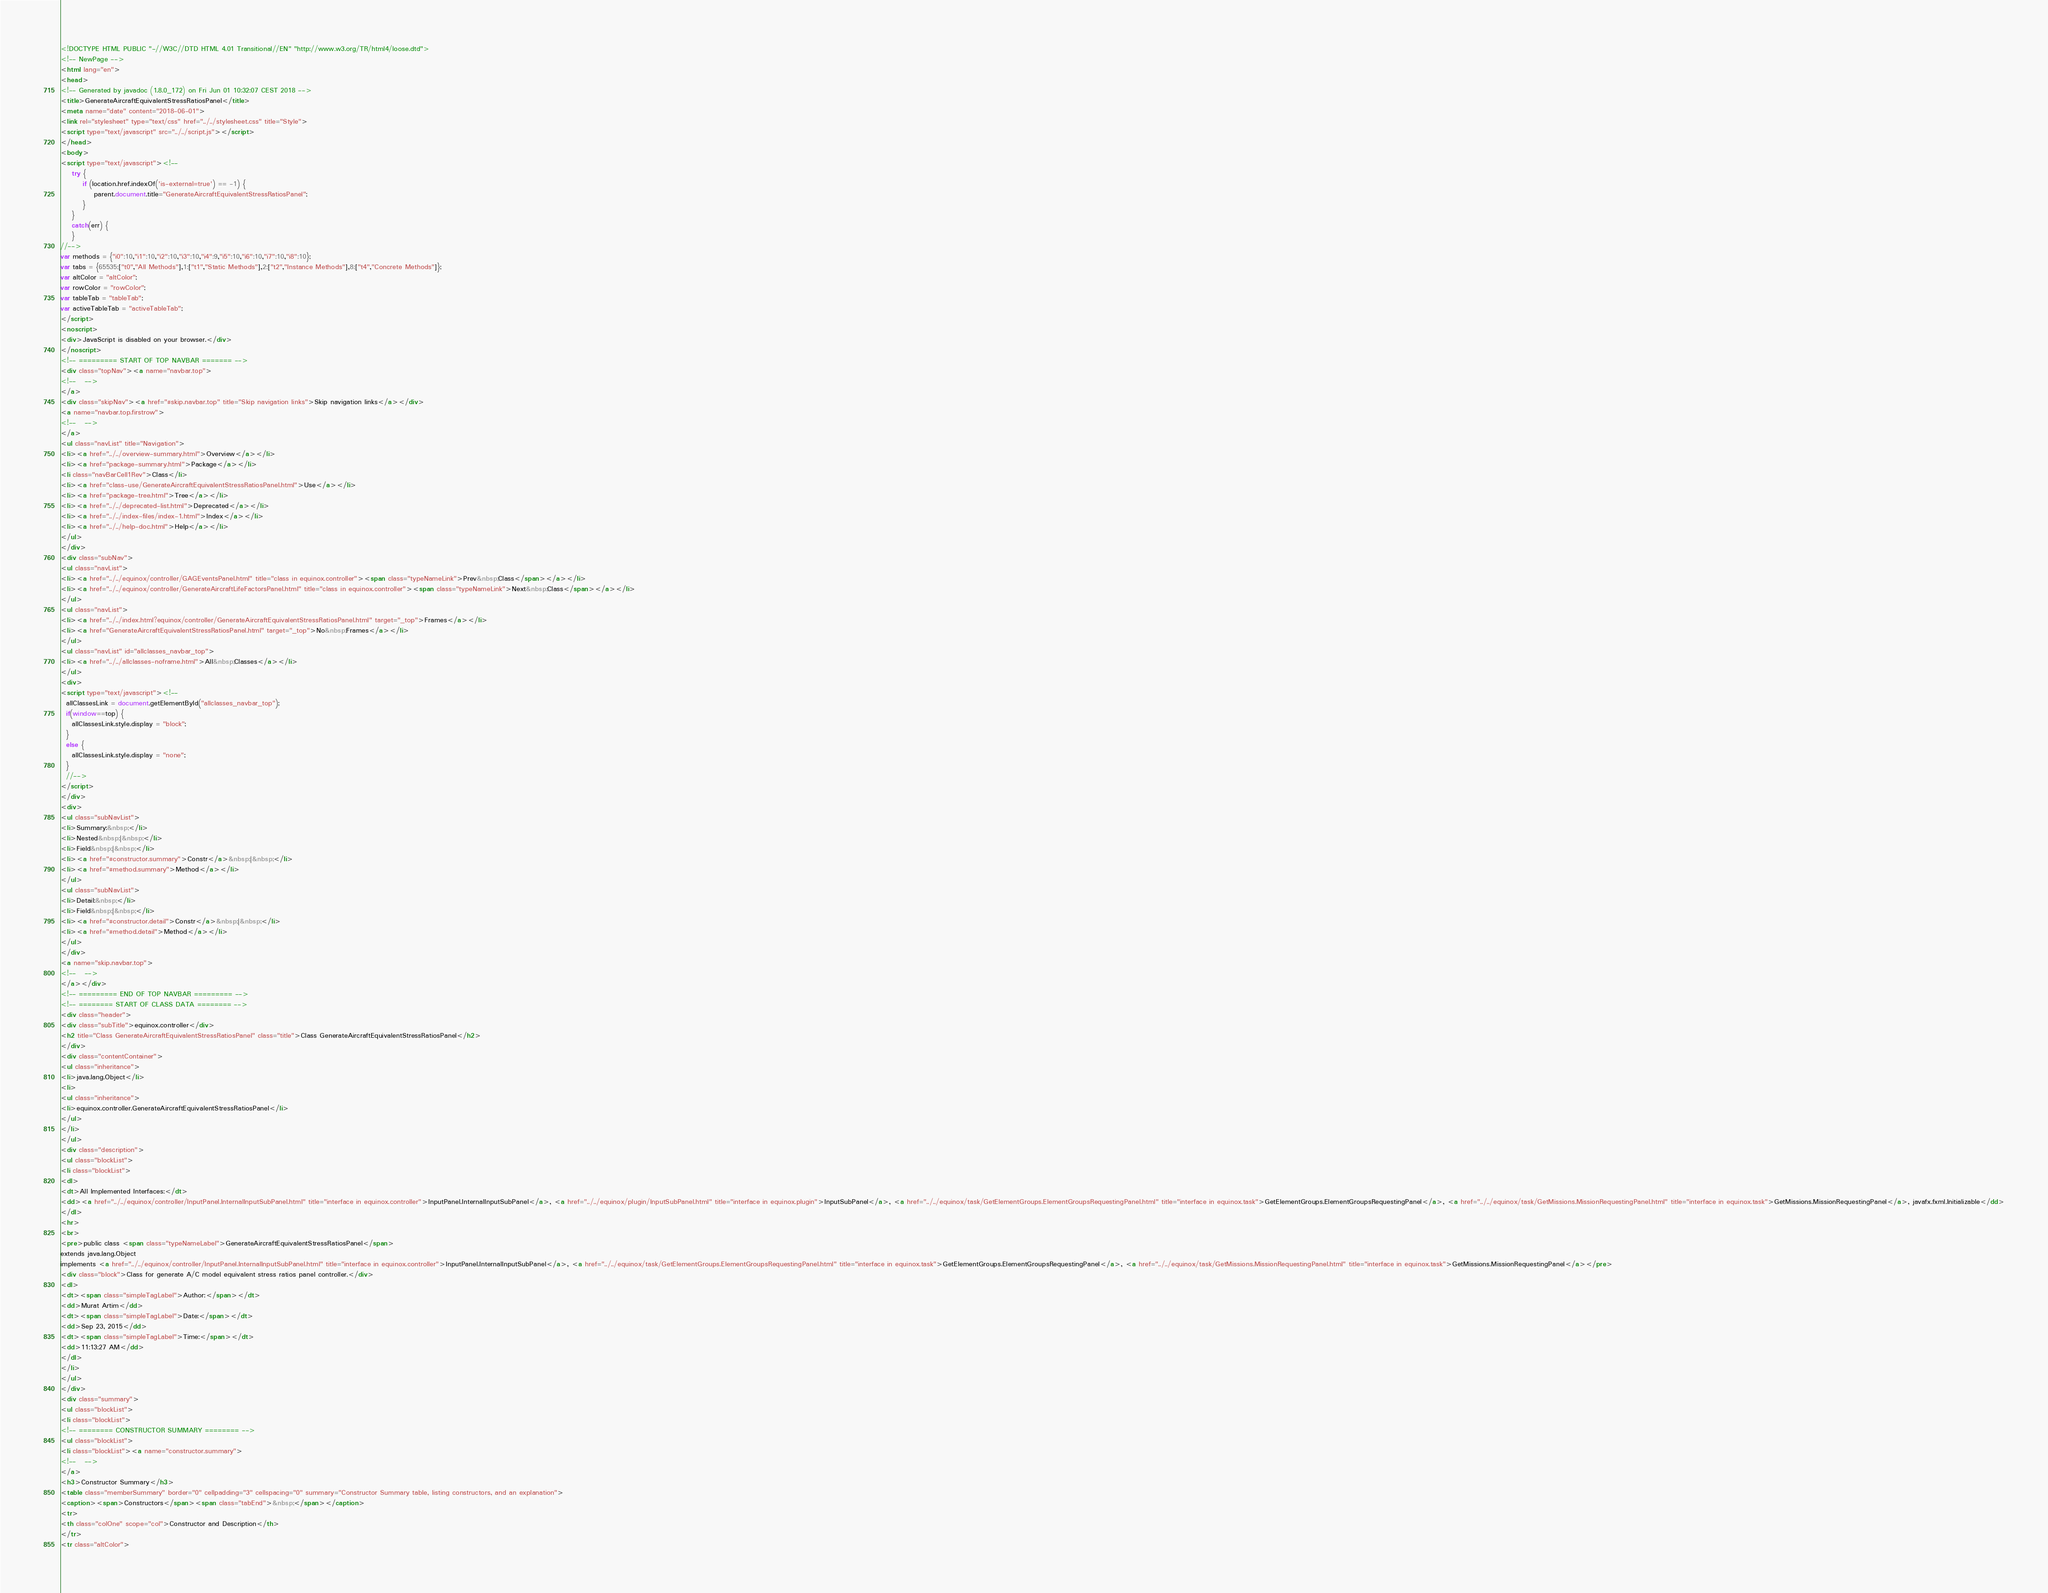<code> <loc_0><loc_0><loc_500><loc_500><_HTML_><!DOCTYPE HTML PUBLIC "-//W3C//DTD HTML 4.01 Transitional//EN" "http://www.w3.org/TR/html4/loose.dtd">
<!-- NewPage -->
<html lang="en">
<head>
<!-- Generated by javadoc (1.8.0_172) on Fri Jun 01 10:32:07 CEST 2018 -->
<title>GenerateAircraftEquivalentStressRatiosPanel</title>
<meta name="date" content="2018-06-01">
<link rel="stylesheet" type="text/css" href="../../stylesheet.css" title="Style">
<script type="text/javascript" src="../../script.js"></script>
</head>
<body>
<script type="text/javascript"><!--
    try {
        if (location.href.indexOf('is-external=true') == -1) {
            parent.document.title="GenerateAircraftEquivalentStressRatiosPanel";
        }
    }
    catch(err) {
    }
//-->
var methods = {"i0":10,"i1":10,"i2":10,"i3":10,"i4":9,"i5":10,"i6":10,"i7":10,"i8":10};
var tabs = {65535:["t0","All Methods"],1:["t1","Static Methods"],2:["t2","Instance Methods"],8:["t4","Concrete Methods"]};
var altColor = "altColor";
var rowColor = "rowColor";
var tableTab = "tableTab";
var activeTableTab = "activeTableTab";
</script>
<noscript>
<div>JavaScript is disabled on your browser.</div>
</noscript>
<!-- ========= START OF TOP NAVBAR ======= -->
<div class="topNav"><a name="navbar.top">
<!--   -->
</a>
<div class="skipNav"><a href="#skip.navbar.top" title="Skip navigation links">Skip navigation links</a></div>
<a name="navbar.top.firstrow">
<!--   -->
</a>
<ul class="navList" title="Navigation">
<li><a href="../../overview-summary.html">Overview</a></li>
<li><a href="package-summary.html">Package</a></li>
<li class="navBarCell1Rev">Class</li>
<li><a href="class-use/GenerateAircraftEquivalentStressRatiosPanel.html">Use</a></li>
<li><a href="package-tree.html">Tree</a></li>
<li><a href="../../deprecated-list.html">Deprecated</a></li>
<li><a href="../../index-files/index-1.html">Index</a></li>
<li><a href="../../help-doc.html">Help</a></li>
</ul>
</div>
<div class="subNav">
<ul class="navList">
<li><a href="../../equinox/controller/GAGEventsPanel.html" title="class in equinox.controller"><span class="typeNameLink">Prev&nbsp;Class</span></a></li>
<li><a href="../../equinox/controller/GenerateAircraftLifeFactorsPanel.html" title="class in equinox.controller"><span class="typeNameLink">Next&nbsp;Class</span></a></li>
</ul>
<ul class="navList">
<li><a href="../../index.html?equinox/controller/GenerateAircraftEquivalentStressRatiosPanel.html" target="_top">Frames</a></li>
<li><a href="GenerateAircraftEquivalentStressRatiosPanel.html" target="_top">No&nbsp;Frames</a></li>
</ul>
<ul class="navList" id="allclasses_navbar_top">
<li><a href="../../allclasses-noframe.html">All&nbsp;Classes</a></li>
</ul>
<div>
<script type="text/javascript"><!--
  allClassesLink = document.getElementById("allclasses_navbar_top");
  if(window==top) {
    allClassesLink.style.display = "block";
  }
  else {
    allClassesLink.style.display = "none";
  }
  //-->
</script>
</div>
<div>
<ul class="subNavList">
<li>Summary:&nbsp;</li>
<li>Nested&nbsp;|&nbsp;</li>
<li>Field&nbsp;|&nbsp;</li>
<li><a href="#constructor.summary">Constr</a>&nbsp;|&nbsp;</li>
<li><a href="#method.summary">Method</a></li>
</ul>
<ul class="subNavList">
<li>Detail:&nbsp;</li>
<li>Field&nbsp;|&nbsp;</li>
<li><a href="#constructor.detail">Constr</a>&nbsp;|&nbsp;</li>
<li><a href="#method.detail">Method</a></li>
</ul>
</div>
<a name="skip.navbar.top">
<!--   -->
</a></div>
<!-- ========= END OF TOP NAVBAR ========= -->
<!-- ======== START OF CLASS DATA ======== -->
<div class="header">
<div class="subTitle">equinox.controller</div>
<h2 title="Class GenerateAircraftEquivalentStressRatiosPanel" class="title">Class GenerateAircraftEquivalentStressRatiosPanel</h2>
</div>
<div class="contentContainer">
<ul class="inheritance">
<li>java.lang.Object</li>
<li>
<ul class="inheritance">
<li>equinox.controller.GenerateAircraftEquivalentStressRatiosPanel</li>
</ul>
</li>
</ul>
<div class="description">
<ul class="blockList">
<li class="blockList">
<dl>
<dt>All Implemented Interfaces:</dt>
<dd><a href="../../equinox/controller/InputPanel.InternalInputSubPanel.html" title="interface in equinox.controller">InputPanel.InternalInputSubPanel</a>, <a href="../../equinox/plugin/InputSubPanel.html" title="interface in equinox.plugin">InputSubPanel</a>, <a href="../../equinox/task/GetElementGroups.ElementGroupsRequestingPanel.html" title="interface in equinox.task">GetElementGroups.ElementGroupsRequestingPanel</a>, <a href="../../equinox/task/GetMissions.MissionRequestingPanel.html" title="interface in equinox.task">GetMissions.MissionRequestingPanel</a>, javafx.fxml.Initializable</dd>
</dl>
<hr>
<br>
<pre>public class <span class="typeNameLabel">GenerateAircraftEquivalentStressRatiosPanel</span>
extends java.lang.Object
implements <a href="../../equinox/controller/InputPanel.InternalInputSubPanel.html" title="interface in equinox.controller">InputPanel.InternalInputSubPanel</a>, <a href="../../equinox/task/GetElementGroups.ElementGroupsRequestingPanel.html" title="interface in equinox.task">GetElementGroups.ElementGroupsRequestingPanel</a>, <a href="../../equinox/task/GetMissions.MissionRequestingPanel.html" title="interface in equinox.task">GetMissions.MissionRequestingPanel</a></pre>
<div class="block">Class for generate A/C model equivalent stress ratios panel controller.</div>
<dl>
<dt><span class="simpleTagLabel">Author:</span></dt>
<dd>Murat Artim</dd>
<dt><span class="simpleTagLabel">Date:</span></dt>
<dd>Sep 23, 2015</dd>
<dt><span class="simpleTagLabel">Time:</span></dt>
<dd>11:13:27 AM</dd>
</dl>
</li>
</ul>
</div>
<div class="summary">
<ul class="blockList">
<li class="blockList">
<!-- ======== CONSTRUCTOR SUMMARY ======== -->
<ul class="blockList">
<li class="blockList"><a name="constructor.summary">
<!--   -->
</a>
<h3>Constructor Summary</h3>
<table class="memberSummary" border="0" cellpadding="3" cellspacing="0" summary="Constructor Summary table, listing constructors, and an explanation">
<caption><span>Constructors</span><span class="tabEnd">&nbsp;</span></caption>
<tr>
<th class="colOne" scope="col">Constructor and Description</th>
</tr>
<tr class="altColor"></code> 